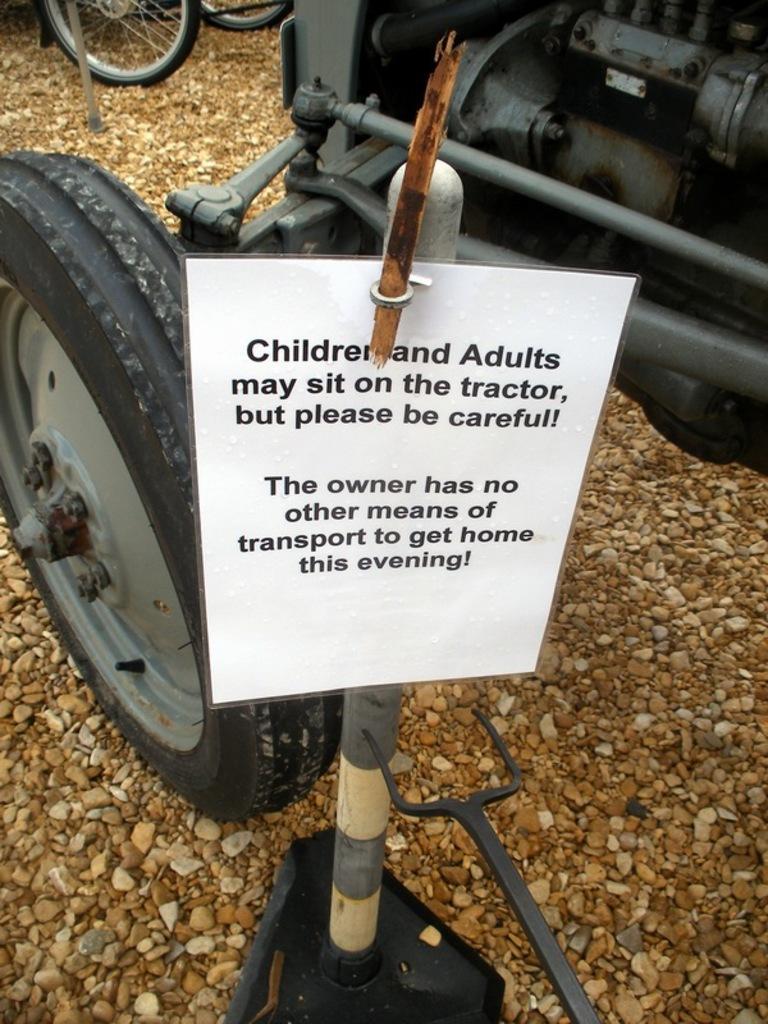How would you summarize this image in a sentence or two? In this image, we can see side view of a vehicle. There are wheels in the top left of the image. There is a board in the middle of the image. 